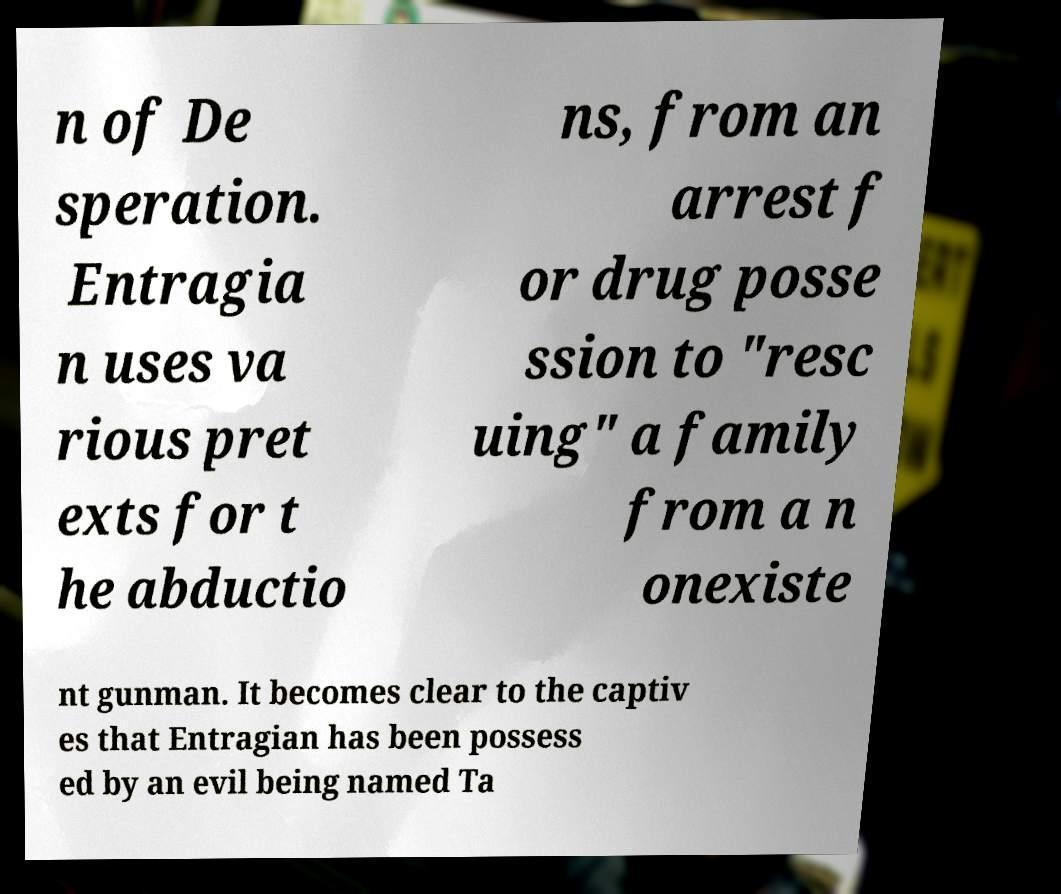Can you read and provide the text displayed in the image?This photo seems to have some interesting text. Can you extract and type it out for me? n of De speration. Entragia n uses va rious pret exts for t he abductio ns, from an arrest f or drug posse ssion to "resc uing" a family from a n onexiste nt gunman. It becomes clear to the captiv es that Entragian has been possess ed by an evil being named Ta 